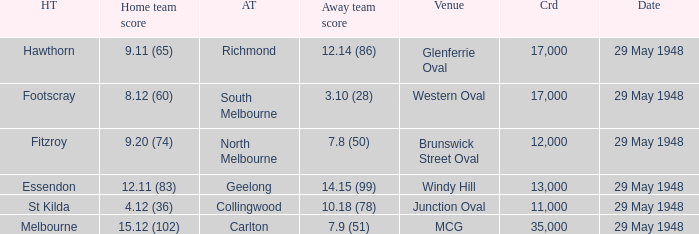In the match where north melbourne was the away team, how much did the home team score? 9.20 (74). 